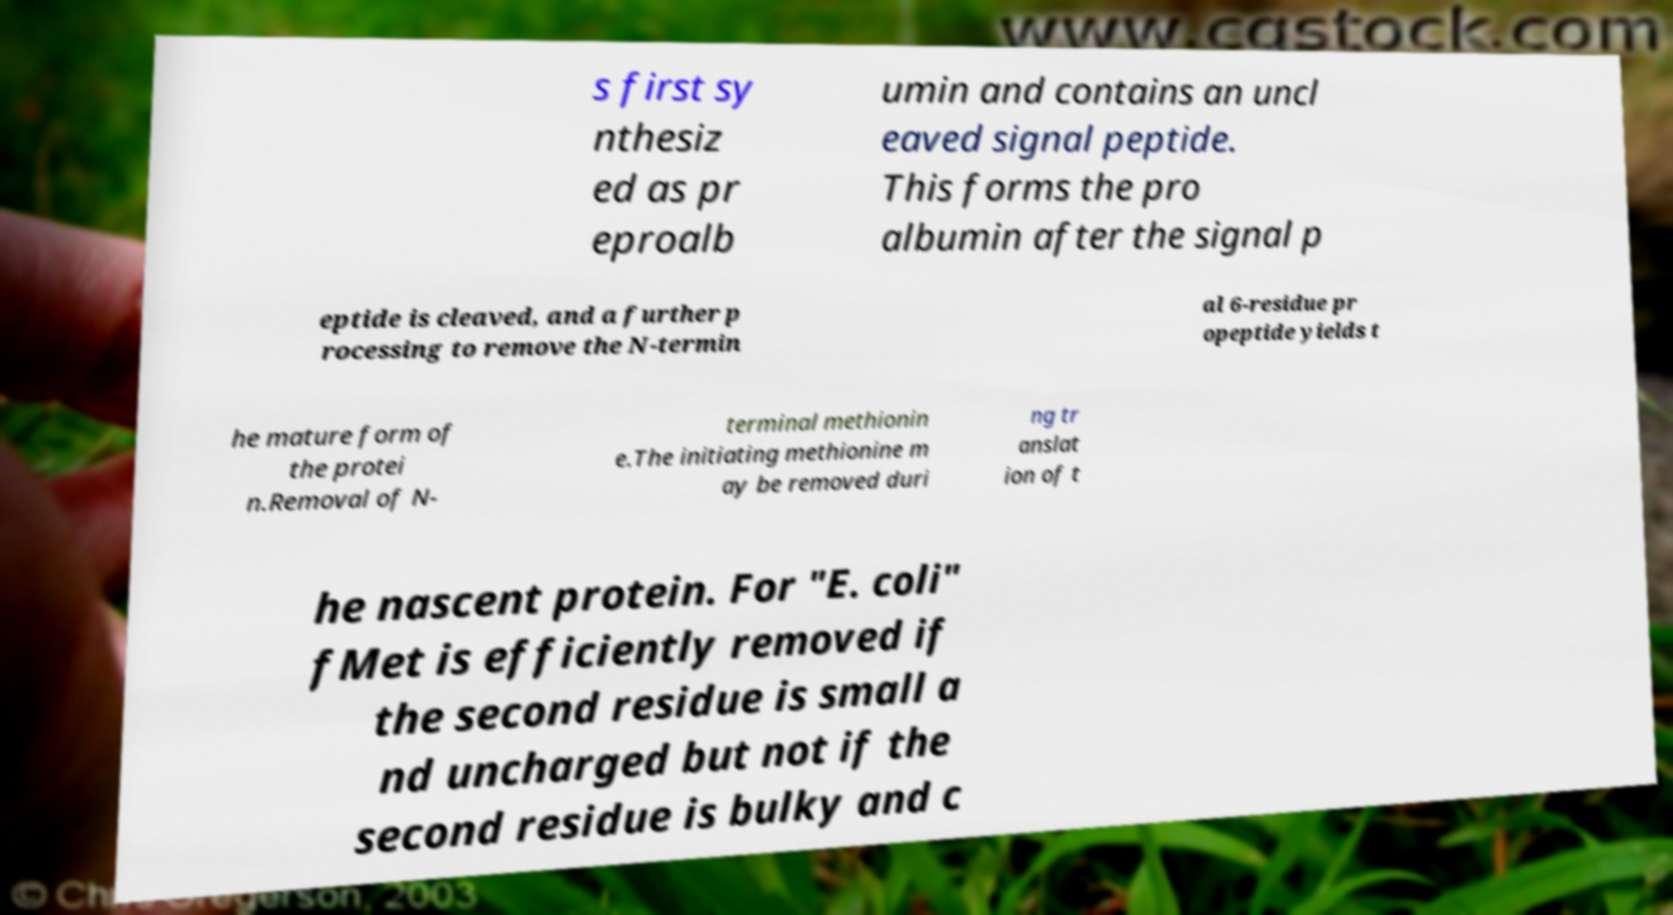What messages or text are displayed in this image? I need them in a readable, typed format. s first sy nthesiz ed as pr eproalb umin and contains an uncl eaved signal peptide. This forms the pro albumin after the signal p eptide is cleaved, and a further p rocessing to remove the N-termin al 6-residue pr opeptide yields t he mature form of the protei n.Removal of N- terminal methionin e.The initiating methionine m ay be removed duri ng tr anslat ion of t he nascent protein. For "E. coli" fMet is efficiently removed if the second residue is small a nd uncharged but not if the second residue is bulky and c 